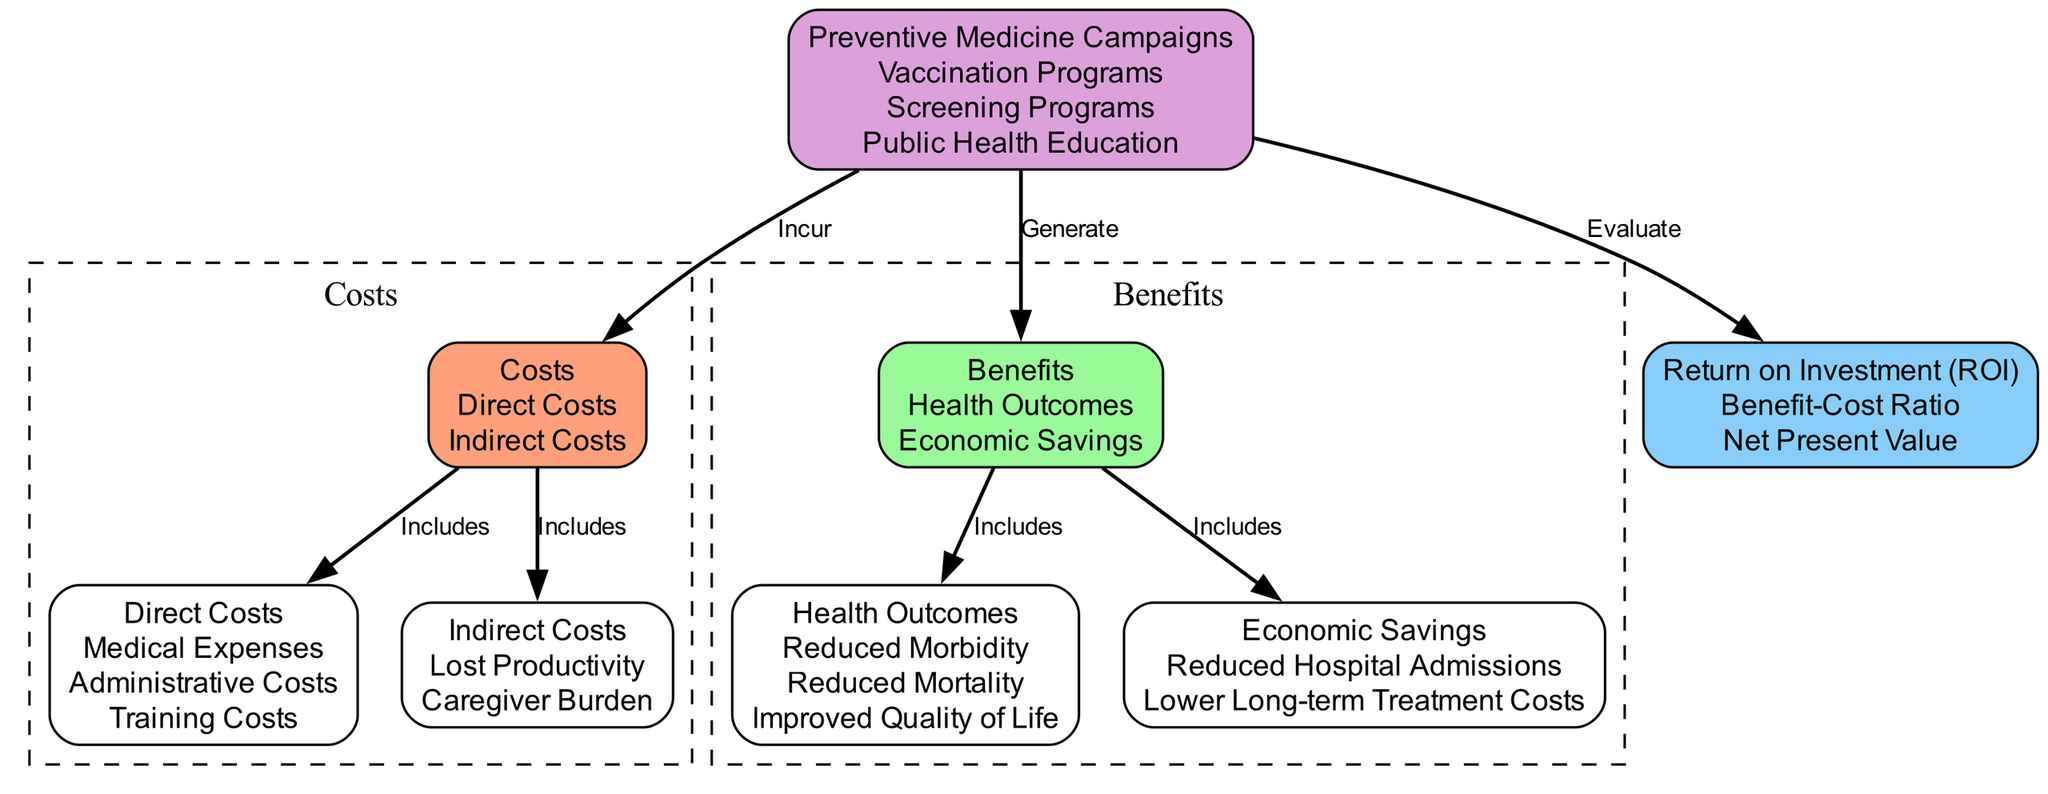What are the two main categories of costs in the diagram? The diagram identifies costs, which are divided into two main categories: direct costs and indirect costs. This can be seen in the "Costs" node connected to both the "Direct Costs" and "Indirect Costs" nodes.
Answer: Direct Costs, Indirect Costs How many benefits are listed in the diagram? The "Benefits" node includes two subcategories: health outcomes and economic savings. Each of these categories contains additional details but the high-level count of benefit categories remains two.
Answer: 2 What is one example of a direct cost related to preventive medicine campaigns? "Training Costs" is listed under the "Direct Costs" node, which is one specific example of a direct cost related to implementing preventive medicine campaigns.
Answer: Training Costs What is the relationship between preventive medicine and ROI in the diagram? The diagram illustrates that preventive medicine campaigns generate benefits and are evaluated for return on investment (ROI). This relationship is represented by an edge showing that preventive medicine evaluates ROI.
Answer: Evaluate Which benefit includes "Reduced Mortality"? "Reduced Mortality" is part of the "Health Outcomes" category, which is connected to the "Benefits" node in the diagram. This connection indicates that it is categorized as a type of benefit.
Answer: Health Outcomes How many types of economic savings are mentioned? The diagram specifies two types of economic savings under the "Economic Savings" node: reduced hospital admissions and lower long-term treatment costs. Therefore, there are two types mentioned.
Answer: 2 What is the benefit-cost ratio associated with? The benefit-cost ratio is part of the "Return on Investment (ROI)" evaluation in the diagram, which indicates it is a measure linked to the effectiveness of the costs relative to the benefits generated from preventive medicine.
Answer: ROI What are the specific health outcomes listed in the diagram? The diagram specifies three health outcomes: reduced morbidity, reduced mortality, and improved quality of life, all categorized under the "Health Outcomes" node.
Answer: Reduced Morbidity, Reduced Mortality, Improved Quality of Life 